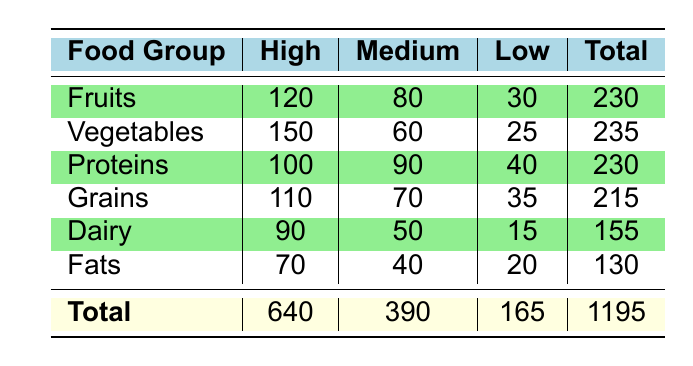What is the total count of individuals adhering to a high diet level? To find the total count of individuals with a high diet adherence level, we need to sum the counts under the "High" column for all food groups: 120 (Fruits) + 150 (Vegetables) + 100 (Proteins) + 110 (Grains) + 90 (Dairy) + 70 (Fats) = 640.
Answer: 640 Which food group has the highest number of individuals with a medium diet adherence level? Looking at the "Medium" column, we can see the counts: 80 (Fruits), 60 (Vegetables), 90 (Proteins), 70 (Grains), 50 (Dairy), and 40 (Fats). The highest count is 90, which corresponds to the Proteins food group.
Answer: Proteins Is the count of low diet adherence individuals in Grains greater than that in Fruits? We need to compare the counts for "Low" in both categories: Grains has 35 and Fruits has 30. Since 35 is greater than 30, the answer is yes.
Answer: Yes What is the average count for the high diet adherence level across all food groups? To find the average, we first sum the high counts: 120 (Fruits) + 150 (Vegetables) + 100 (Proteins) + 110 (Grains) + 90 (Dairy) + 70 (Fats) = 640. Then, divide by the number of food groups, which is 6: 640 / 6 = 106.67.
Answer: 106.67 Is there more than one food group that has a total count (High + Medium + Low) exceeding 200? We can calculate the total for each food group: Fruits = 230, Vegetables = 235, Proteins = 230, Grains = 215, Dairy = 155, Fats = 130. The groups exceeding 200 are Fruits, Vegetables, Proteins, and Grains. Since there are four groups, the answer is yes.
Answer: Yes What is the difference in the count of low adherence individuals between Vegetables and Dairy? For Vegetables, the count is 25, and for Dairy, it is 15. The difference is calculated as 25 - 15 = 10.
Answer: 10 Which food group has the lowest total count of individuals across all adherence levels? We compare the total counts: Fruits = 230, Vegetables = 235, Proteins = 230, Grains = 215, Dairy = 155, and Fats = 130. Fats has the lowest total count of 130.
Answer: Fats How many more individuals adhere to a high diet level than a low diet level in the Dairy category? The counts in Dairy are 90 for high and 15 for low. The difference is 90 - 15 = 75, signifying 75 more individuals adhere at a high level.
Answer: 75 